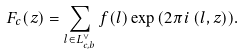Convert formula to latex. <formula><loc_0><loc_0><loc_500><loc_500>F _ { c } ( z ) = \sum _ { l \in L _ { c , b } ^ { \vee } } f ( l ) \exp { ( 2 \pi i \, ( l , z ) ) } .</formula> 